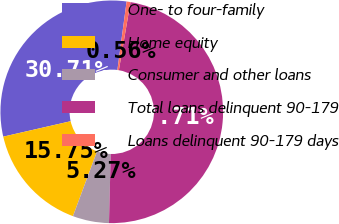Convert chart. <chart><loc_0><loc_0><loc_500><loc_500><pie_chart><fcel>One- to four-family<fcel>Home equity<fcel>Consumer and other loans<fcel>Total loans delinquent 90-179<fcel>Loans delinquent 90-179 days<nl><fcel>30.71%<fcel>15.75%<fcel>5.27%<fcel>47.71%<fcel>0.56%<nl></chart> 